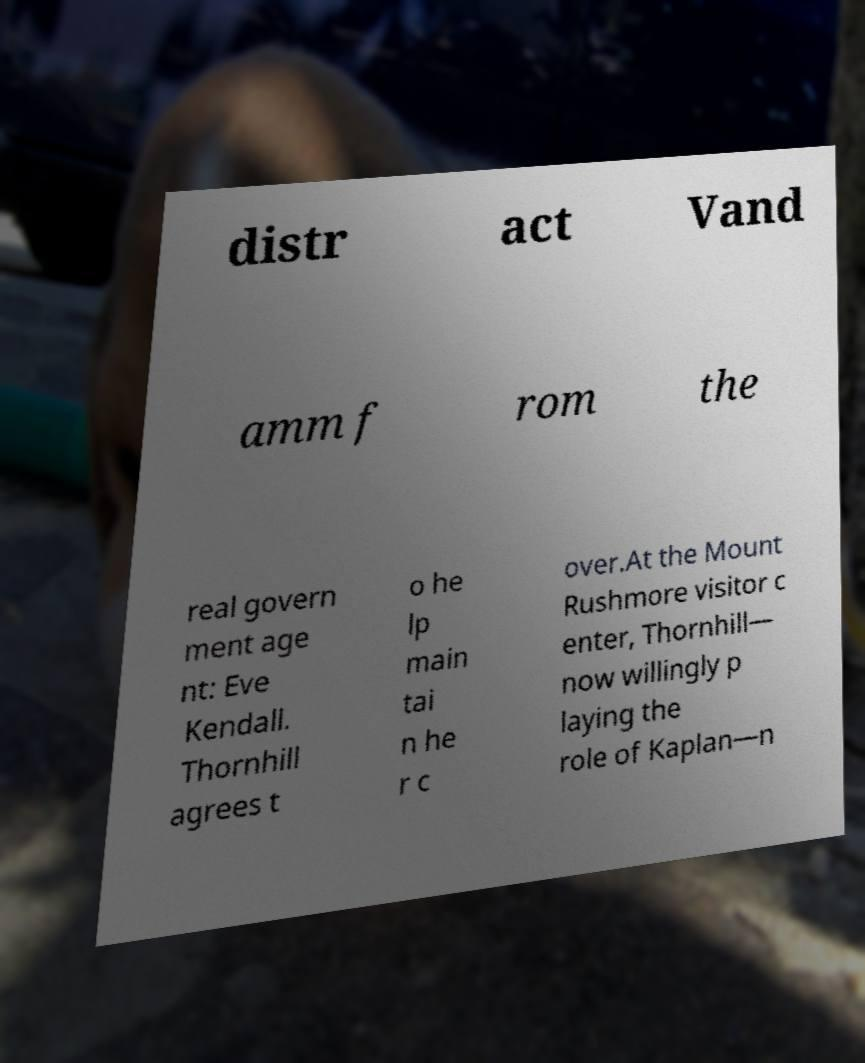For documentation purposes, I need the text within this image transcribed. Could you provide that? distr act Vand amm f rom the real govern ment age nt: Eve Kendall. Thornhill agrees t o he lp main tai n he r c over.At the Mount Rushmore visitor c enter, Thornhill— now willingly p laying the role of Kaplan—n 